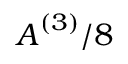<formula> <loc_0><loc_0><loc_500><loc_500>A ^ { ( 3 ) } / 8</formula> 